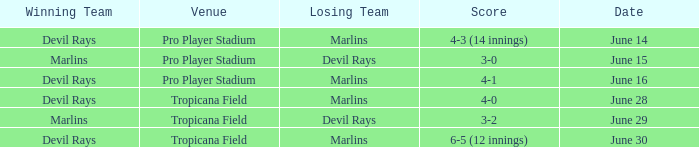Parse the table in full. {'header': ['Winning Team', 'Venue', 'Losing Team', 'Score', 'Date'], 'rows': [['Devil Rays', 'Pro Player Stadium', 'Marlins', '4-3 (14 innings)', 'June 14'], ['Marlins', 'Pro Player Stadium', 'Devil Rays', '3-0', 'June 15'], ['Devil Rays', 'Pro Player Stadium', 'Marlins', '4-1', 'June 16'], ['Devil Rays', 'Tropicana Field', 'Marlins', '4-0', 'June 28'], ['Marlins', 'Tropicana Field', 'Devil Rays', '3-2', 'June 29'], ['Devil Rays', 'Tropicana Field', 'Marlins', '6-5 (12 innings)', 'June 30']]} What was the score on june 29 when the devil rays los? 3-2. 